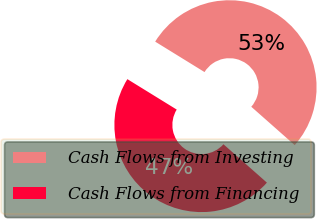Convert chart. <chart><loc_0><loc_0><loc_500><loc_500><pie_chart><fcel>Cash Flows from Investing<fcel>Cash Flows from Financing<nl><fcel>52.72%<fcel>47.28%<nl></chart> 